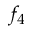Convert formula to latex. <formula><loc_0><loc_0><loc_500><loc_500>f _ { 4 }</formula> 